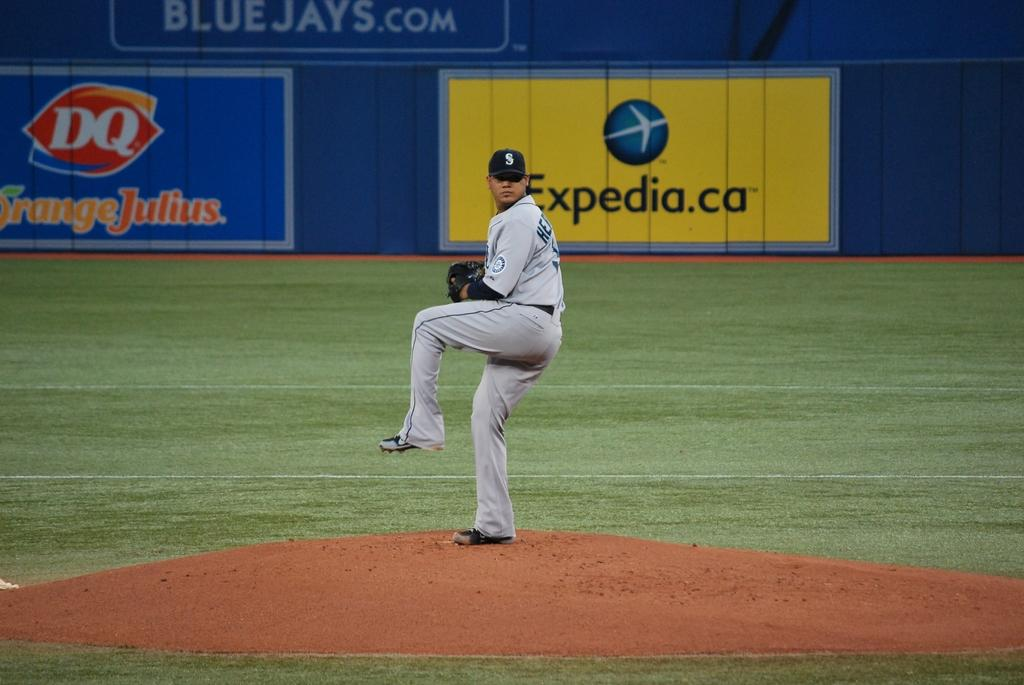<image>
Offer a succinct explanation of the picture presented. In front of an Expedia billboard, a baseball pitcher readies himself to throw. 